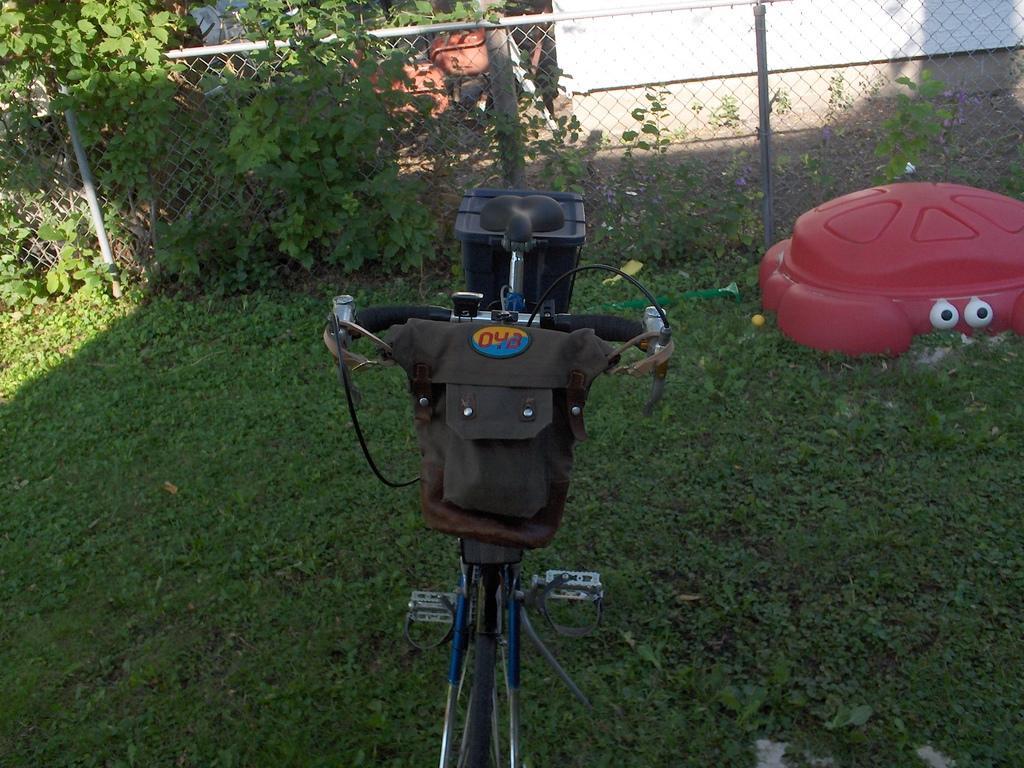Can you describe this image briefly? In this picture I can see full of grass, on the grass we can see bicycle and tube is placed, behind we can see fence and we can see white color wall. 